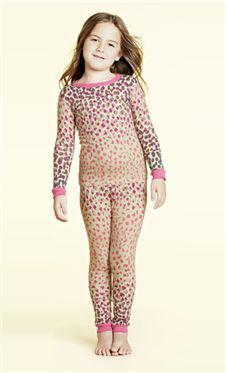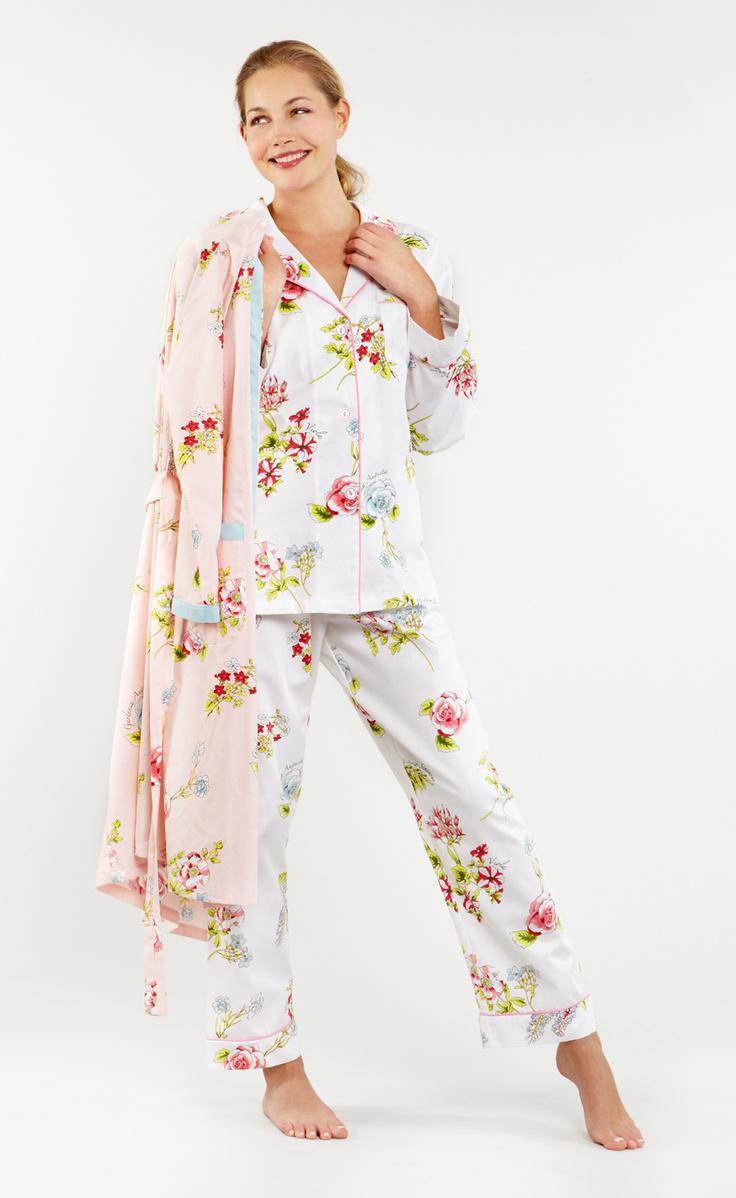The first image is the image on the left, the second image is the image on the right. Assess this claim about the two images: "The woman in the image on the left has her feet close together.". Correct or not? Answer yes or no. Yes. The first image is the image on the left, the second image is the image on the right. Considering the images on both sides, is "An adult woman in one image is wearing a printed pajama set with tight fitting pants that have wide, solid-color cuffs at the ankles." valid? Answer yes or no. No. 